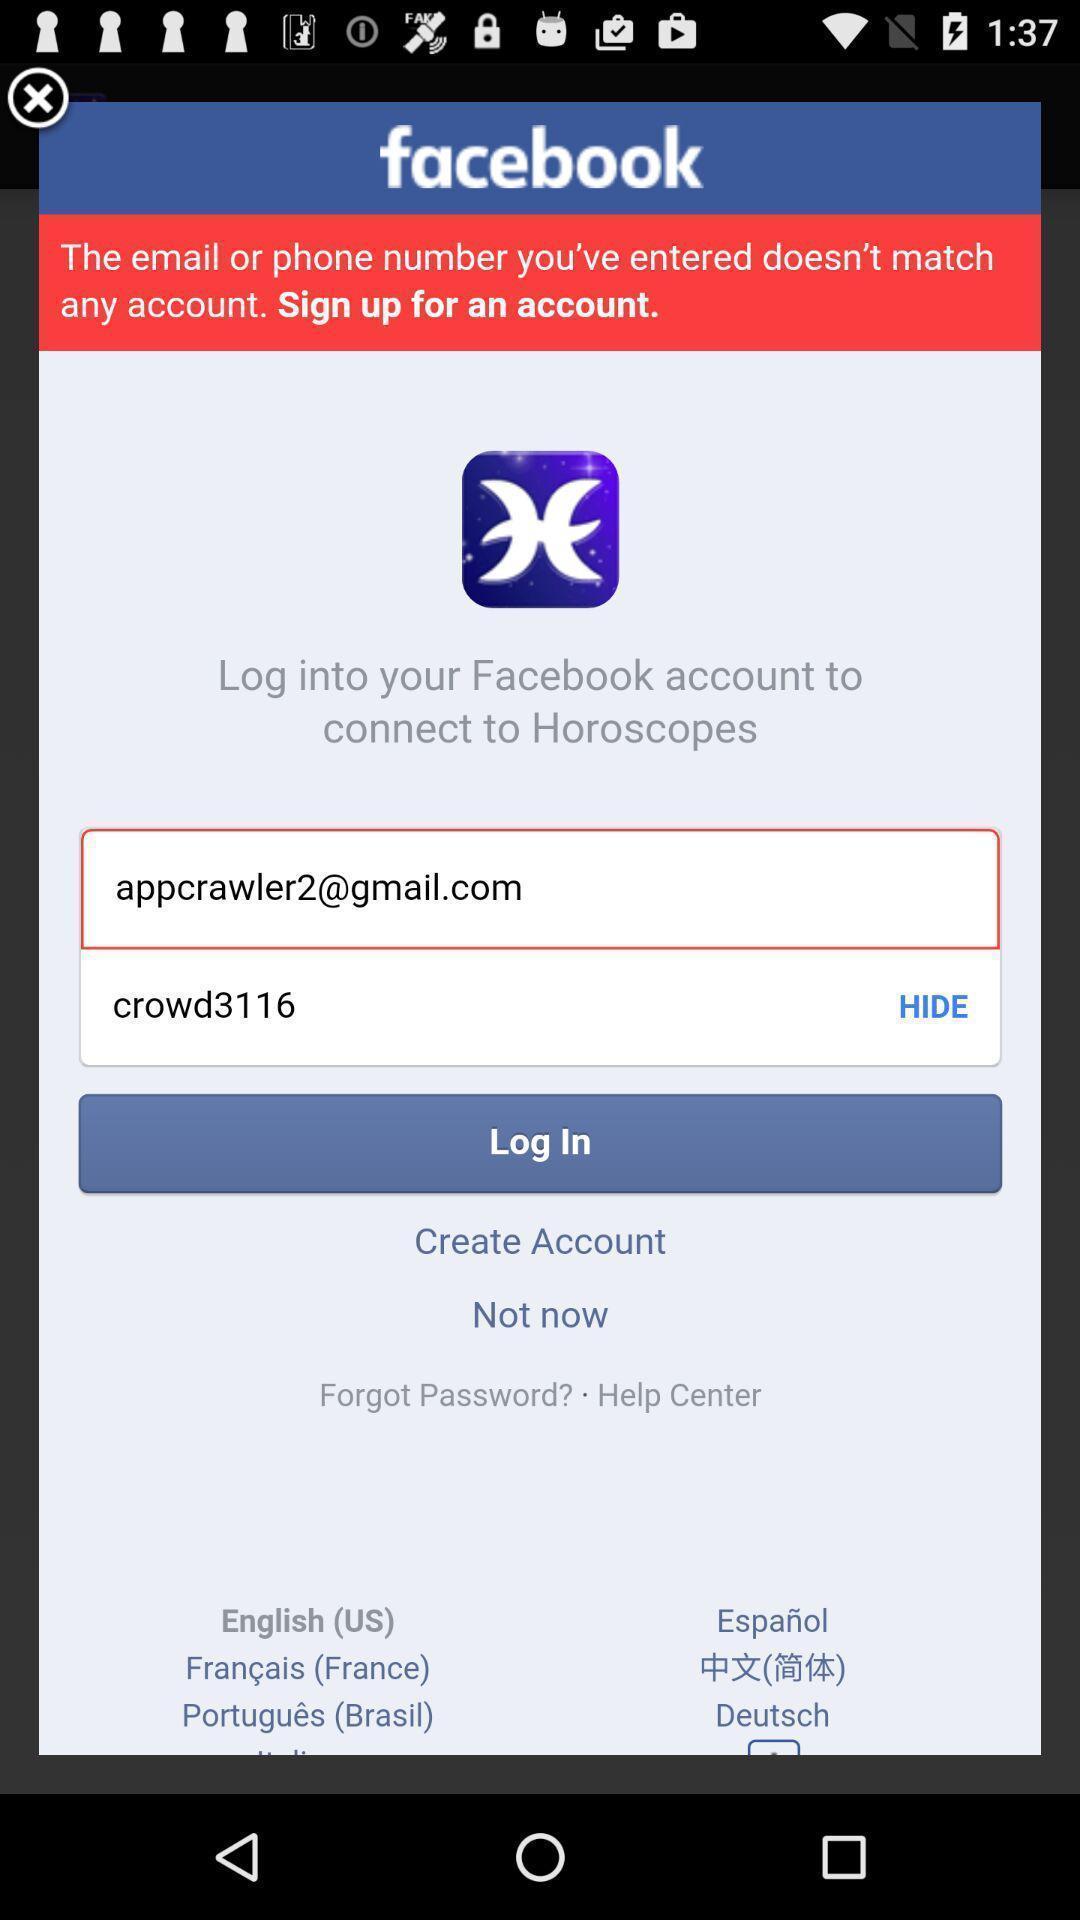Tell me what you see in this picture. Pop-up to login to a social app. 